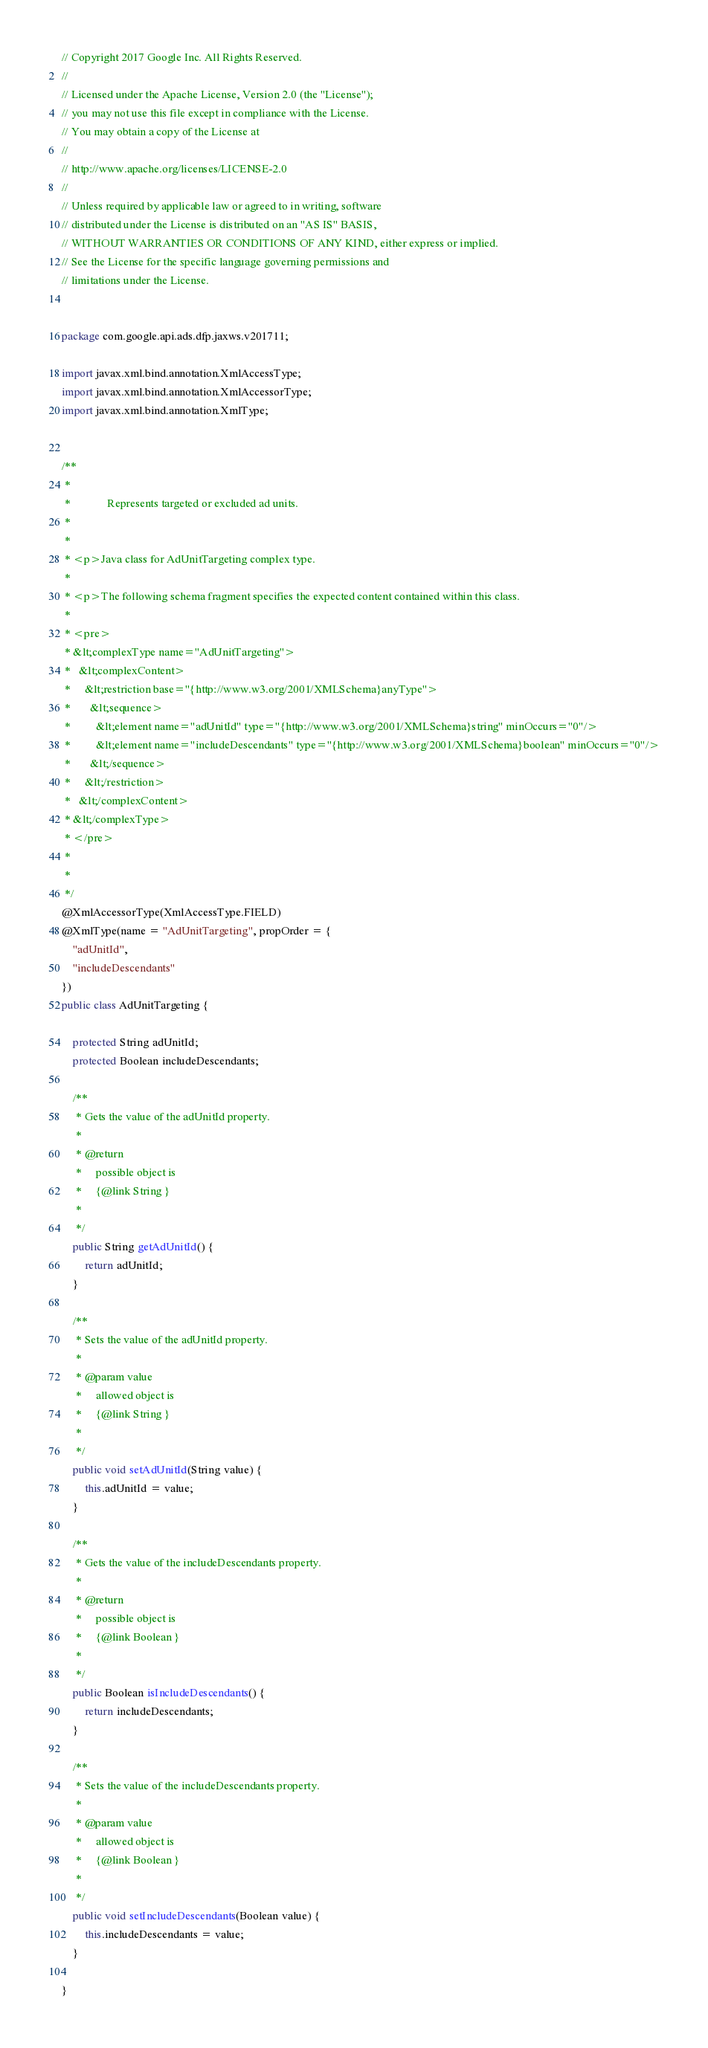Convert code to text. <code><loc_0><loc_0><loc_500><loc_500><_Java_>// Copyright 2017 Google Inc. All Rights Reserved.
//
// Licensed under the Apache License, Version 2.0 (the "License");
// you may not use this file except in compliance with the License.
// You may obtain a copy of the License at
//
// http://www.apache.org/licenses/LICENSE-2.0
//
// Unless required by applicable law or agreed to in writing, software
// distributed under the License is distributed on an "AS IS" BASIS,
// WITHOUT WARRANTIES OR CONDITIONS OF ANY KIND, either express or implied.
// See the License for the specific language governing permissions and
// limitations under the License.


package com.google.api.ads.dfp.jaxws.v201711;

import javax.xml.bind.annotation.XmlAccessType;
import javax.xml.bind.annotation.XmlAccessorType;
import javax.xml.bind.annotation.XmlType;


/**
 * 
 *             Represents targeted or excluded ad units.
 *           
 * 
 * <p>Java class for AdUnitTargeting complex type.
 * 
 * <p>The following schema fragment specifies the expected content contained within this class.
 * 
 * <pre>
 * &lt;complexType name="AdUnitTargeting">
 *   &lt;complexContent>
 *     &lt;restriction base="{http://www.w3.org/2001/XMLSchema}anyType">
 *       &lt;sequence>
 *         &lt;element name="adUnitId" type="{http://www.w3.org/2001/XMLSchema}string" minOccurs="0"/>
 *         &lt;element name="includeDescendants" type="{http://www.w3.org/2001/XMLSchema}boolean" minOccurs="0"/>
 *       &lt;/sequence>
 *     &lt;/restriction>
 *   &lt;/complexContent>
 * &lt;/complexType>
 * </pre>
 * 
 * 
 */
@XmlAccessorType(XmlAccessType.FIELD)
@XmlType(name = "AdUnitTargeting", propOrder = {
    "adUnitId",
    "includeDescendants"
})
public class AdUnitTargeting {

    protected String adUnitId;
    protected Boolean includeDescendants;

    /**
     * Gets the value of the adUnitId property.
     * 
     * @return
     *     possible object is
     *     {@link String }
     *     
     */
    public String getAdUnitId() {
        return adUnitId;
    }

    /**
     * Sets the value of the adUnitId property.
     * 
     * @param value
     *     allowed object is
     *     {@link String }
     *     
     */
    public void setAdUnitId(String value) {
        this.adUnitId = value;
    }

    /**
     * Gets the value of the includeDescendants property.
     * 
     * @return
     *     possible object is
     *     {@link Boolean }
     *     
     */
    public Boolean isIncludeDescendants() {
        return includeDescendants;
    }

    /**
     * Sets the value of the includeDescendants property.
     * 
     * @param value
     *     allowed object is
     *     {@link Boolean }
     *     
     */
    public void setIncludeDescendants(Boolean value) {
        this.includeDescendants = value;
    }

}
</code> 